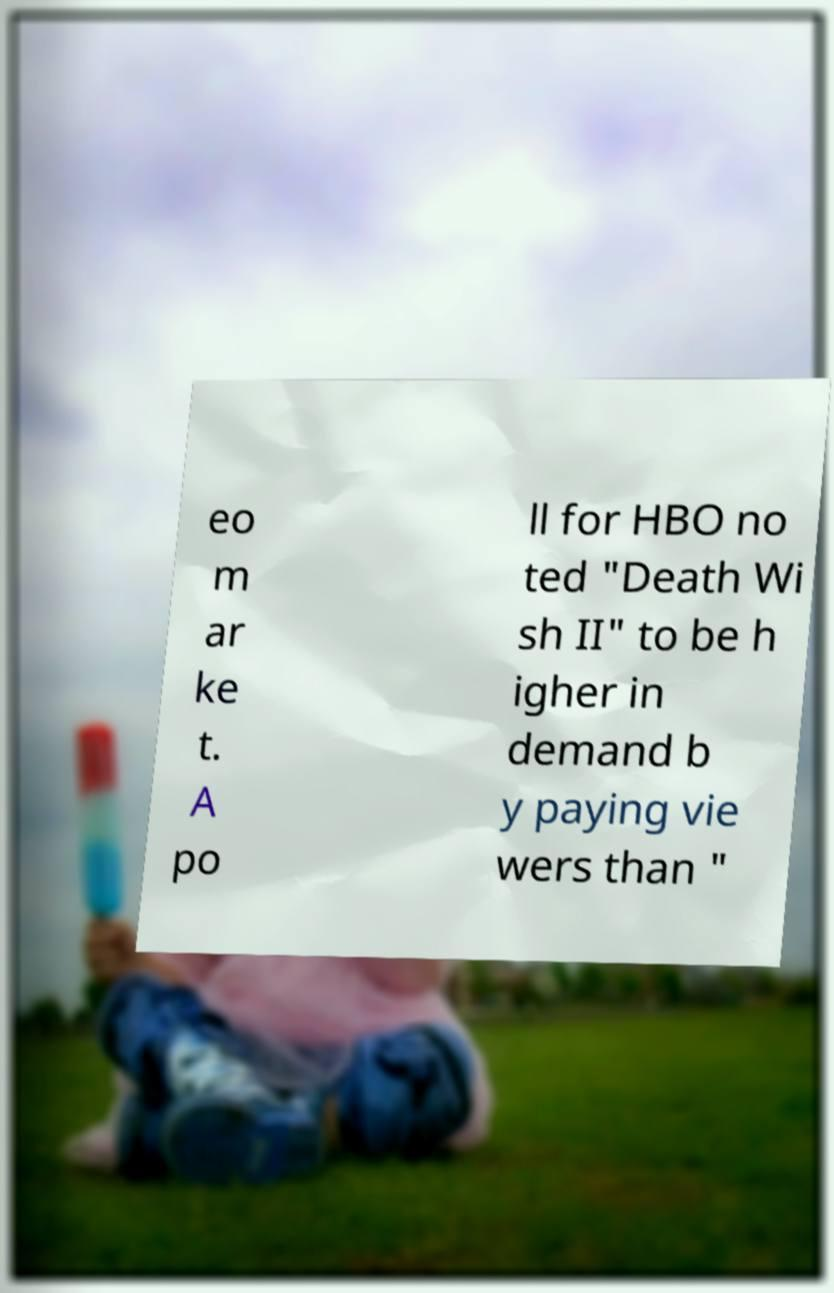I need the written content from this picture converted into text. Can you do that? eo m ar ke t. A po ll for HBO no ted "Death Wi sh II" to be h igher in demand b y paying vie wers than " 